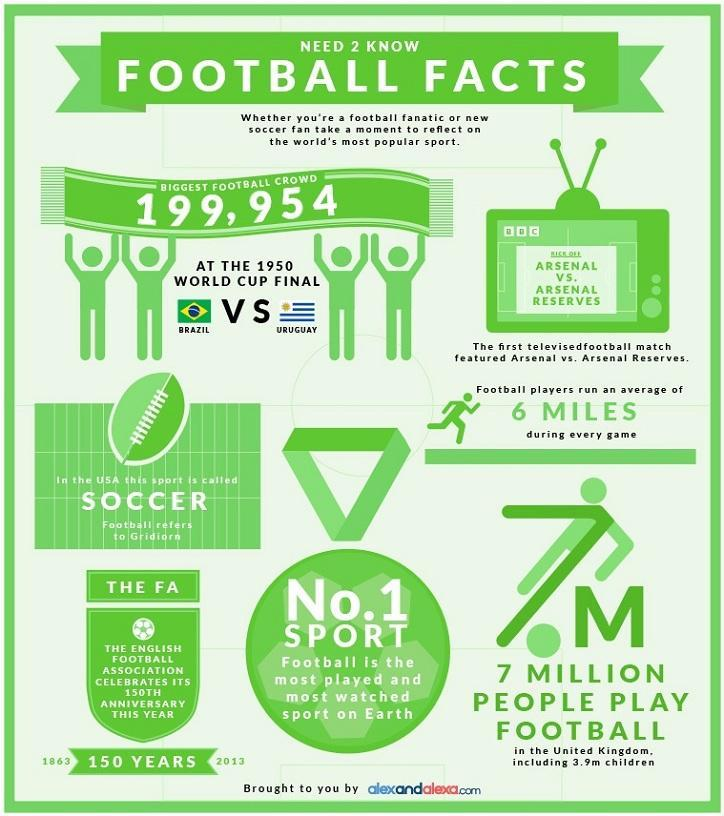How many children in the UK play football as of 2013?
Answer the question with a short phrase. 3.9 When was the English Football Association found in the United Kingdom? 1863 Which two teams played the football world cup finals in 1950? BRAZIL, URUGUAY 